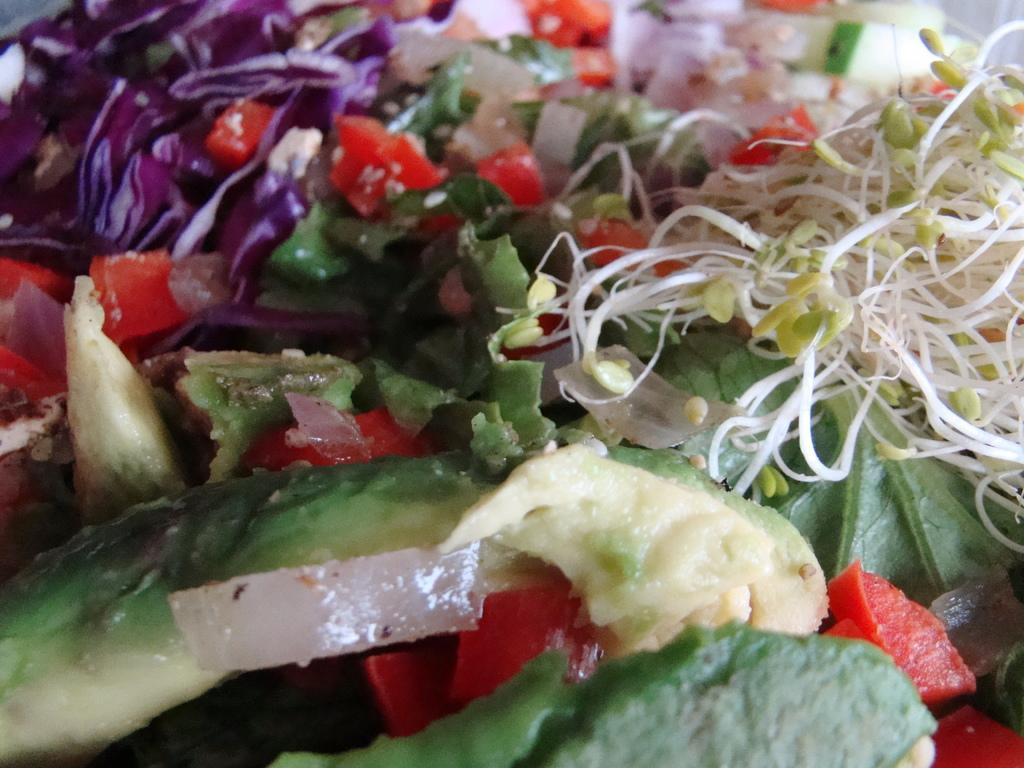What types of items can be seen in the image? There are food items in the image. How many horses are present in the image? There are no horses present in the image; it only contains food items. What type of fruit is the quince in the image? There is no quince present in the image. 